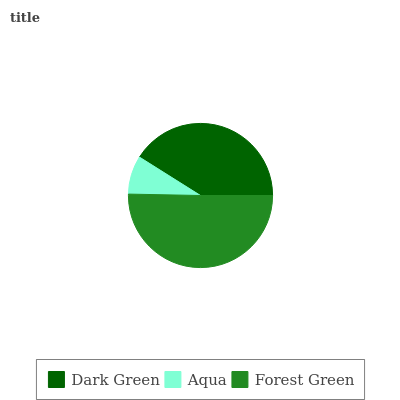Is Aqua the minimum?
Answer yes or no. Yes. Is Forest Green the maximum?
Answer yes or no. Yes. Is Forest Green the minimum?
Answer yes or no. No. Is Aqua the maximum?
Answer yes or no. No. Is Forest Green greater than Aqua?
Answer yes or no. Yes. Is Aqua less than Forest Green?
Answer yes or no. Yes. Is Aqua greater than Forest Green?
Answer yes or no. No. Is Forest Green less than Aqua?
Answer yes or no. No. Is Dark Green the high median?
Answer yes or no. Yes. Is Dark Green the low median?
Answer yes or no. Yes. Is Forest Green the high median?
Answer yes or no. No. Is Aqua the low median?
Answer yes or no. No. 